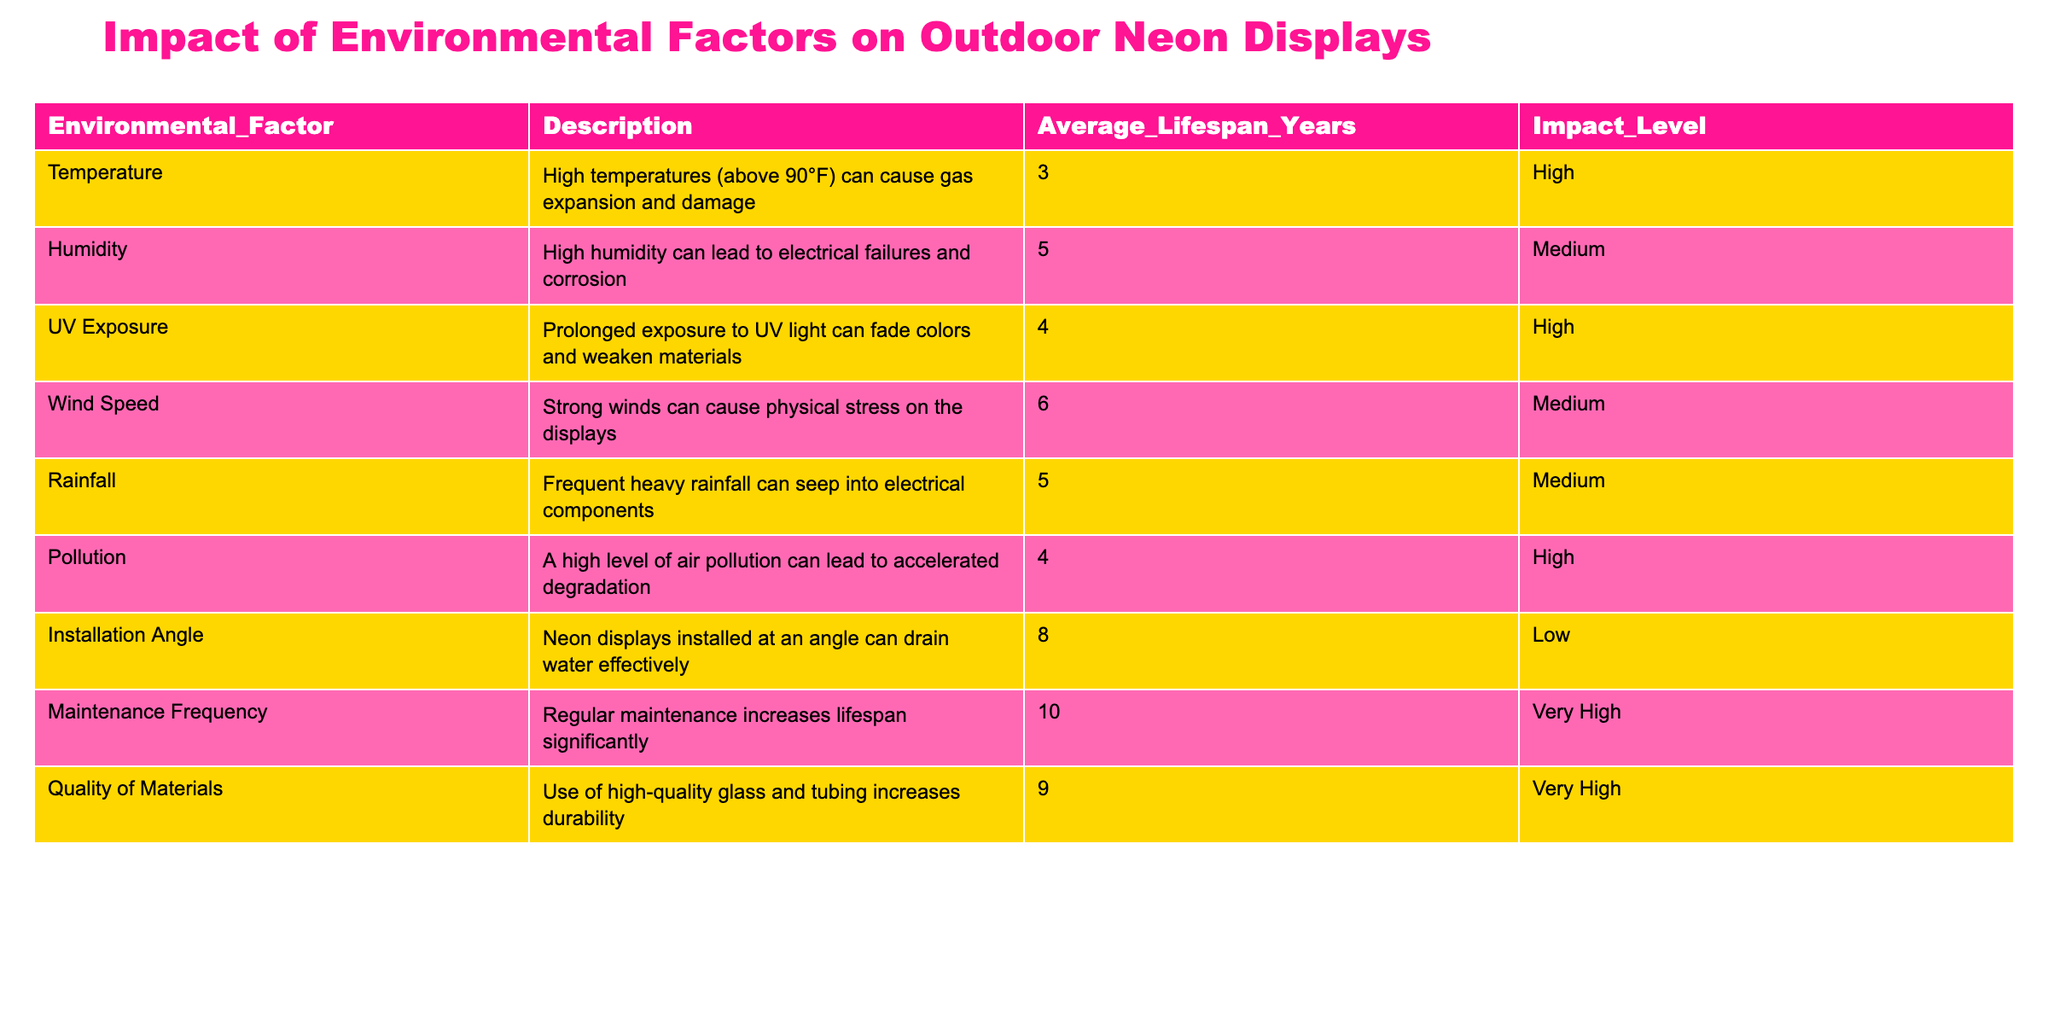What is the average lifespan of neon displays in high humidity? The table shows that high humidity has an average lifespan of 5 years. Therefore, the average lifespan for neon displays under this environmental factor is directly taken as per the table.
Answer: 5 Which environmental factor has the highest average lifespan? By comparing the average lifespan values of all environmental factors listed in the table, we see that maintenance frequency has the highest average lifespan of 10 years.
Answer: 10 Is the impact level of UV exposure high? Yes, the table indicates that UV exposure has been identified as a high impact environmental factor, marked as such in the impact level column.
Answer: Yes What is the combined average lifespan of neon displays affected by high temperatures and air pollution? The average lifespan for high temperatures is 3 years, and for pollution, it is 4 years. Adding these values gives 3 + 4 = 7 years as the combined average lifespan.
Answer: 7 What is the difference in average lifespan between displays installed at an angle and those affected by strong winds? The average lifespan for installation angle is 8 years, and for wind speed, it is 6 years. The difference is calculated as 8 - 6 = 2 years.
Answer: 2 How many environmental factors have a medium impact level? The table lists three environmental factors with a medium impact level: humidity, wind speed, and rainfall, totaling three factors. Count these factors manually or by referencing the table directly to arrive at the answer.
Answer: 3 Which environmental factor contributes most significantly to increasing lifespan? According to the table, regular maintenance frequency is highlighted as having a very high impact on lifespan, with an average lifespan of 10 years. This suggests its significant contribution to increasing the lifespan of the displays.
Answer: Maintenance frequency Are high temperatures considered to have a very high impact on the lifespan of neon displays? No, the table classifies high temperatures as having a high impact level, but not very high, thus indicating it does not significantly impact as per the listed assessments.
Answer: No What is the average lifespan for neon displays exposed to pollution compared to those subjected to high humidity? Pollution has an average lifespan of 4 years, while high humidity has an average lifespan of 5 years. The comparison shows that high humidity provides a longer lifespan by 1 year when compared to pollution.
Answer: 5 years vs 4 years 